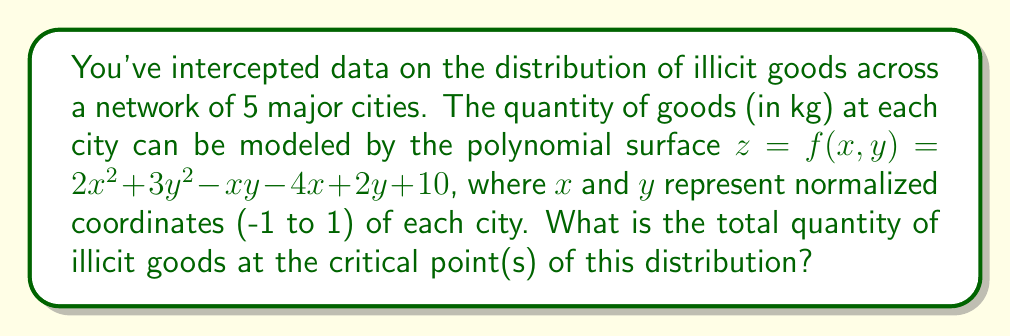Can you answer this question? To solve this problem, we need to follow these steps:

1) Find the critical points by taking partial derivatives and setting them to zero:

   $\frac{\partial f}{\partial x} = 4x - y - 4 = 0$
   $\frac{\partial f}{\partial y} = 6y - x + 2 = 0$

2) Solve the system of equations:
   
   From the second equation: $x = 6y + 2$
   Substitute into the first equation:
   $4(6y + 2) - y - 4 = 0$
   $24y + 8 - y - 4 = 0$
   $23y = -4$
   $y = -\frac{4}{23}$

   Substitute back to find $x$:
   $x = 6(-\frac{4}{23}) + 2 = -\frac{24}{23} + 2 = \frac{22}{23}$

3) The critical point is $(\frac{22}{23}, -\frac{4}{23})$

4) Calculate the quantity at this point by substituting into the original function:

   $z = 2(\frac{22}{23})^2 + 3(-\frac{4}{23})^2 - (\frac{22}{23})(-\frac{4}{23}) - 4(\frac{22}{23}) + 2(-\frac{4}{23}) + 10$

5) Simplify:
   
   $z = 2(\frac{484}{529}) + 3(\frac{16}{529}) + \frac{88}{529} - \frac{88}{23} - \frac{8}{23} + 10$
   
   $z = \frac{968}{529} + \frac{48}{529} + \frac{88}{529} - \frac{88}{23} - \frac{8}{23} + 10$
   
   $z = \frac{1104}{529} - \frac{96}{23} + 10$
   
   $z = \frac{1104}{529} - \frac{2208}{529} + \frac{5290}{529}$
   
   $z = \frac{4186}{529} \approx 7.91$

Thus, the quantity of illicit goods at the critical point is approximately 7.91 kg.
Answer: 7.91 kg 